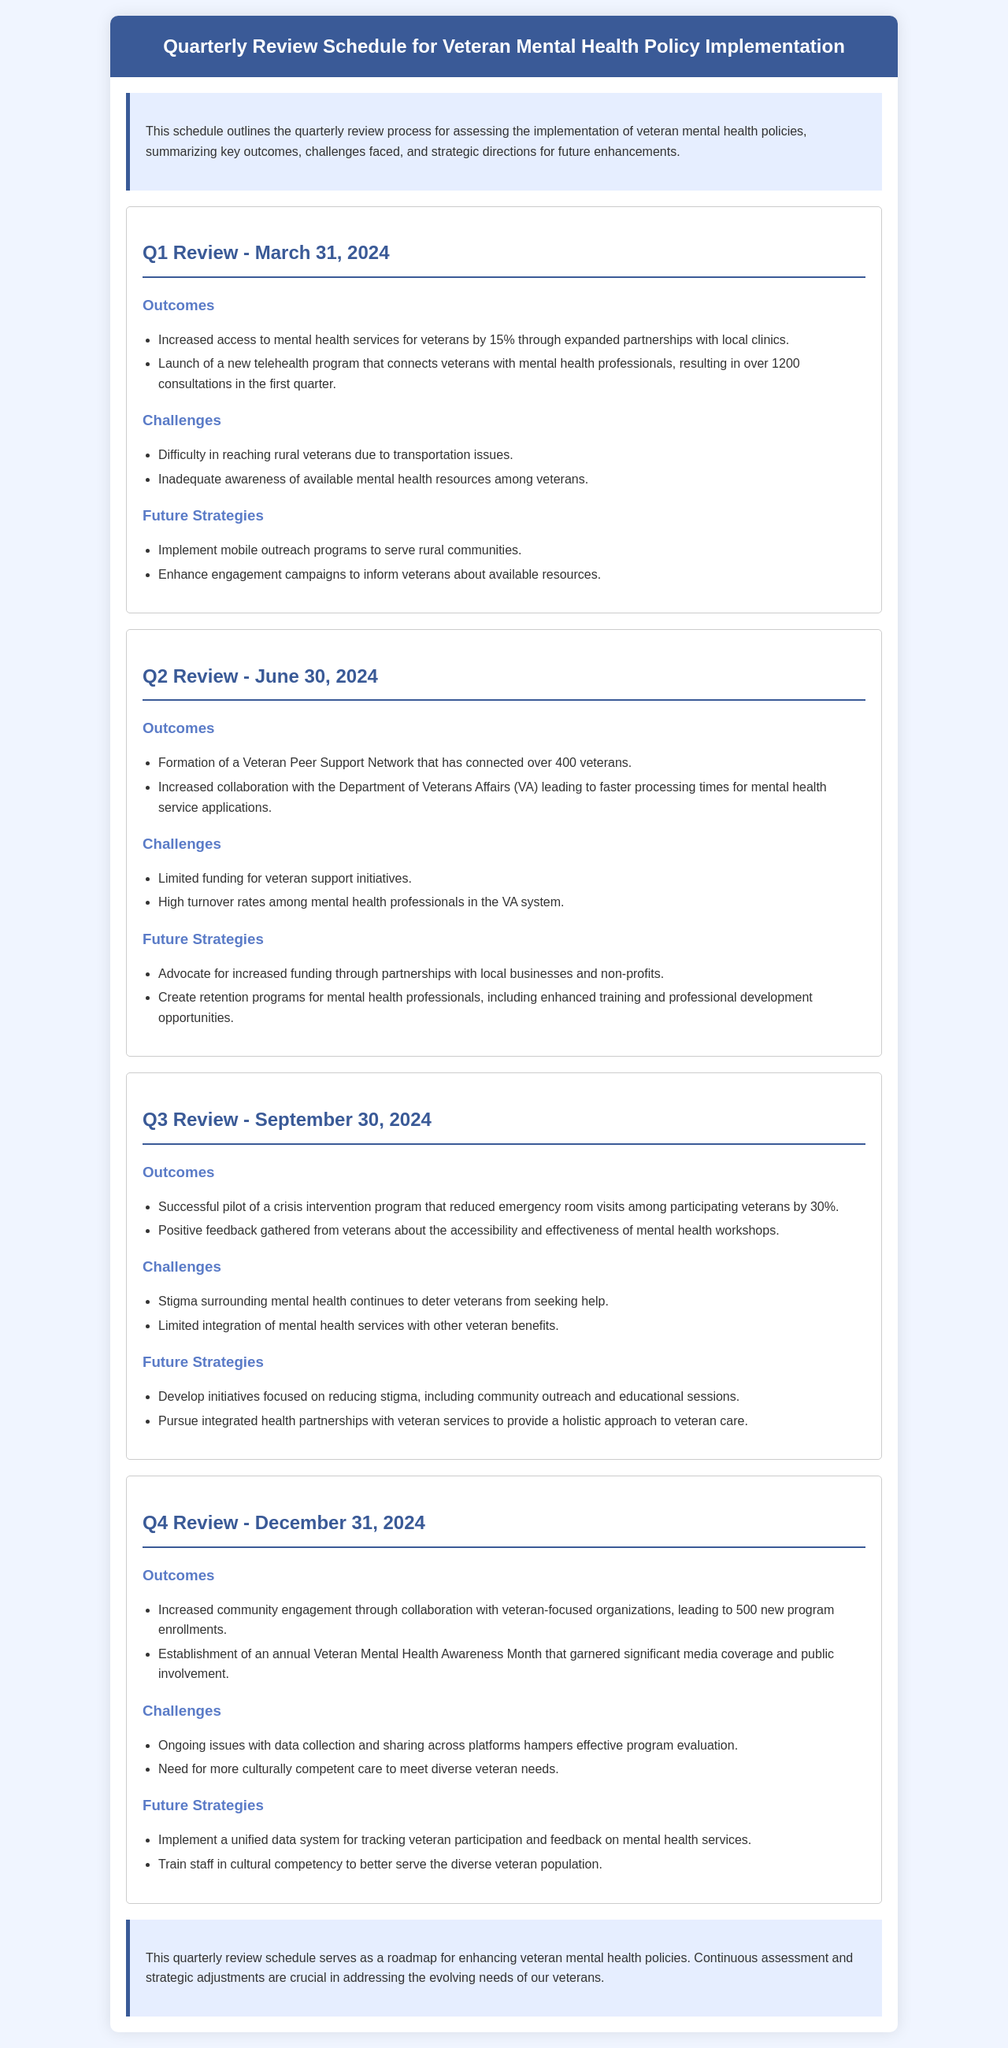What is the date of the Q1 Review? The date for the Q1 Review is provided as March 31, 2024.
Answer: March 31, 2024 How much did access to mental health services increase in Q1? The increase in access to mental health services for veterans is stated as 15%.
Answer: 15% How many veterans were connected through the Veteran Peer Support Network in Q2? The document states that over 400 veterans were connected through this network in Q2.
Answer: 400 What program reduced emergency room visits by 30% in Q3? The successful pilot of a crisis intervention program is mentioned as having reduced emergency room visits.
Answer: crisis intervention program What specific event was established in Q4 to promote mental health awareness? The document mentions the establishment of an annual Veteran Mental Health Awareness Month.
Answer: Veteran Mental Health Awareness Month What challenge was noted in Q1 regarding veterans’ transportation? The document states that there was difficulty in reaching rural veterans due to transportation issues.
Answer: transportation issues Which department's collaboration led to faster processing times in Q2? The document indicates that increased collaboration was achieved with the Department of Veterans Affairs (VA).
Answer: Department of Veterans Affairs What future strategy aims to address the stigma surrounding mental health? The document outlines the development of initiatives focused on reducing stigma as a future strategy.
Answer: reducing stigma What was a recognized challenge regarding data in Q4? The document highlights ongoing issues with data collection and sharing as a challenge.
Answer: data collection and sharing 